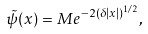<formula> <loc_0><loc_0><loc_500><loc_500>\tilde { \psi } ( x ) = M e ^ { - 2 ( \delta | x | ) ^ { 1 / 2 } } ,</formula> 